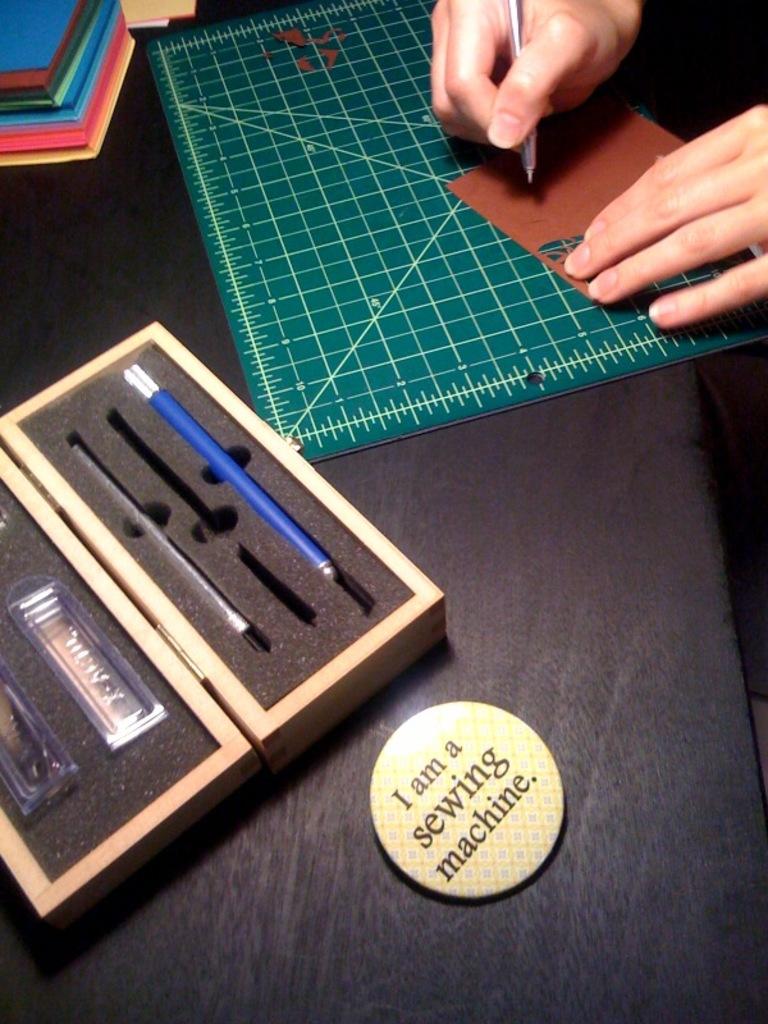What kind of machine does the button refer too?
Your response must be concise. Sewing. What color are the letters on the button?
Your answer should be compact. Black. 